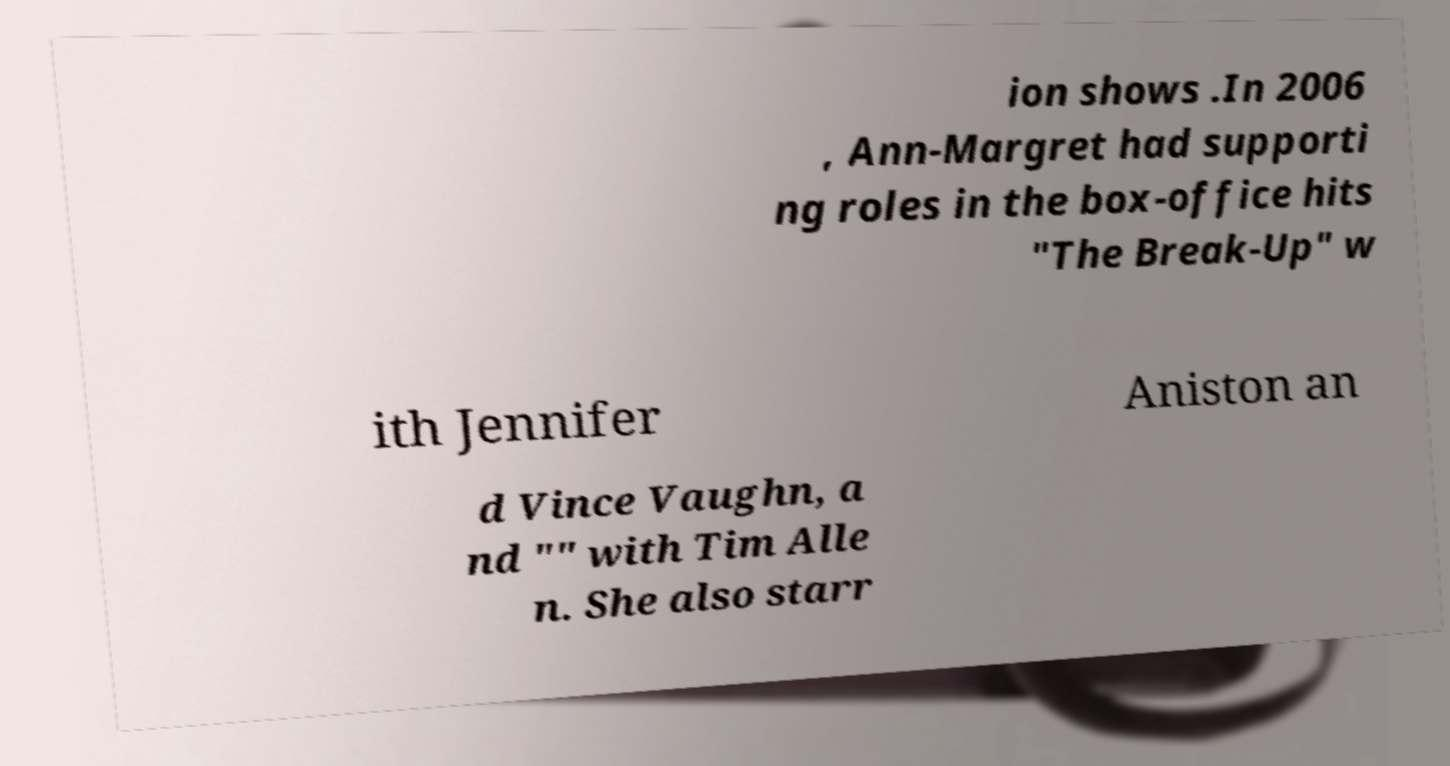Can you read and provide the text displayed in the image?This photo seems to have some interesting text. Can you extract and type it out for me? ion shows .In 2006 , Ann-Margret had supporti ng roles in the box-office hits "The Break-Up" w ith Jennifer Aniston an d Vince Vaughn, a nd "" with Tim Alle n. She also starr 